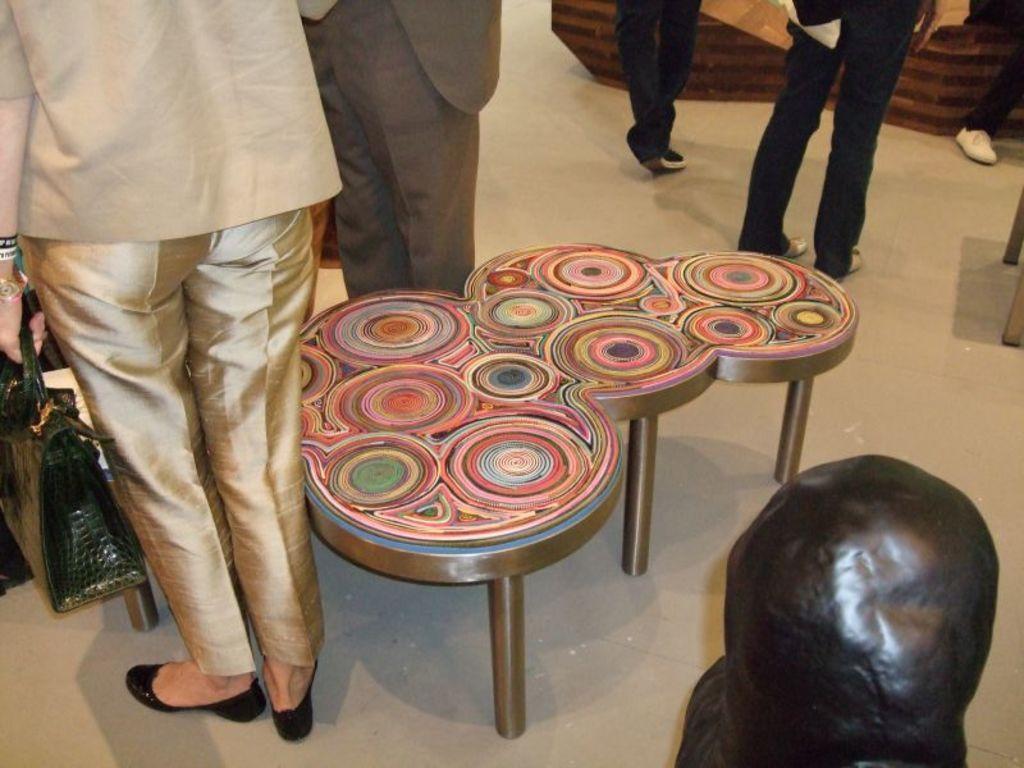In one or two sentences, can you explain what this image depicts? In this image we can see a group of people standing on the floor. One woman is holding a bag in her hand. In the center of the image we can see a table placed on the floor. In the foreground we can see a statue. 